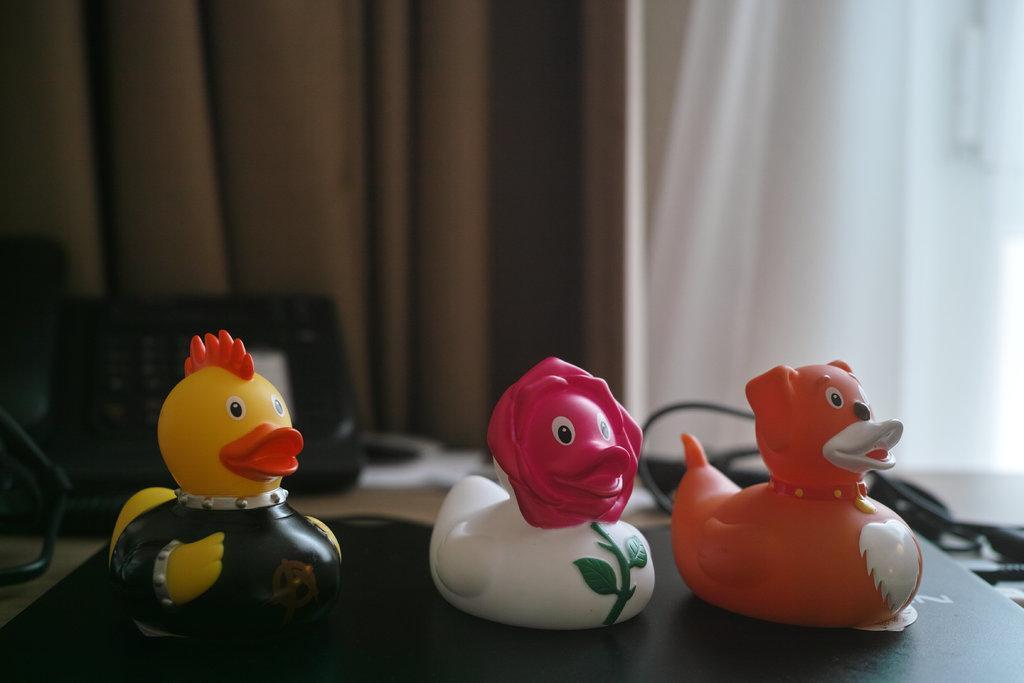Can you describe this image briefly? In this image we can see toy ducks placed on the laptop. In the background we can see telephone, curtains and cables. 